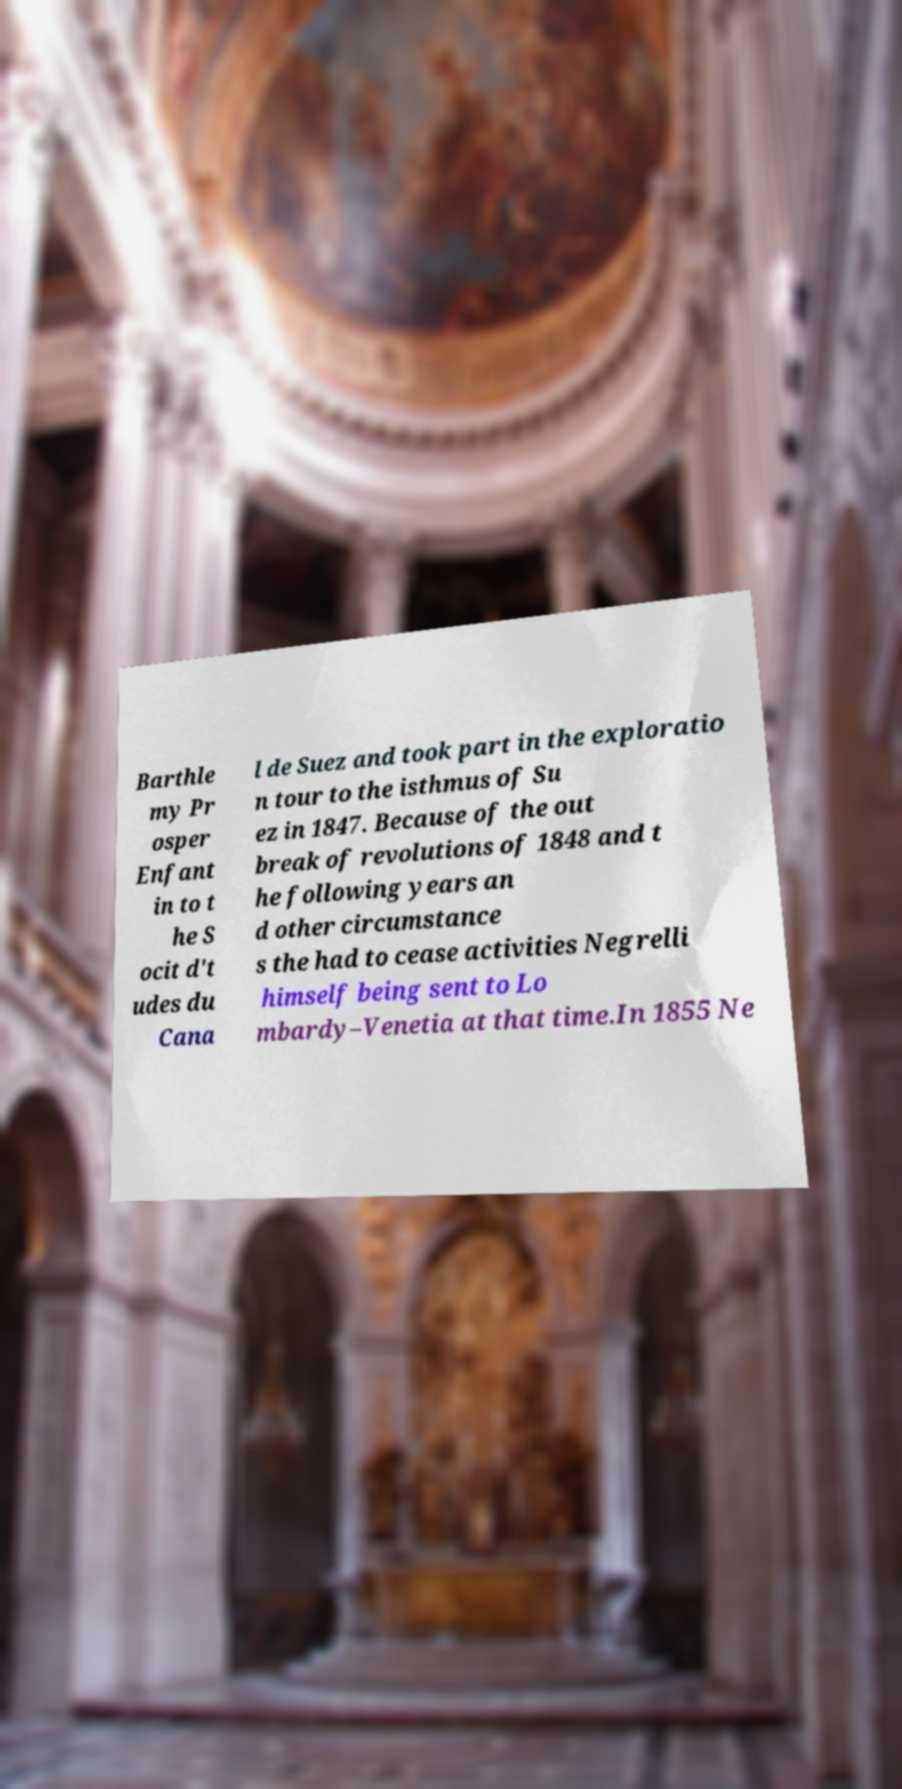Could you assist in decoding the text presented in this image and type it out clearly? Barthle my Pr osper Enfant in to t he S ocit d't udes du Cana l de Suez and took part in the exploratio n tour to the isthmus of Su ez in 1847. Because of the out break of revolutions of 1848 and t he following years an d other circumstance s the had to cease activities Negrelli himself being sent to Lo mbardy–Venetia at that time.In 1855 Ne 